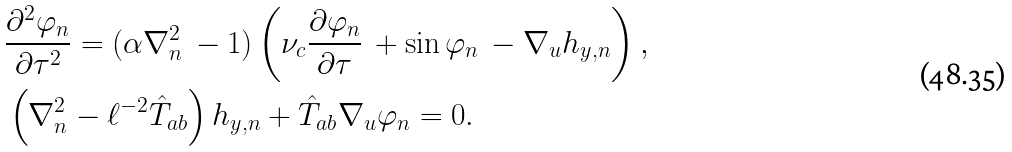Convert formula to latex. <formula><loc_0><loc_0><loc_500><loc_500>& \frac { \partial ^ { 2 } \varphi _ { n } } { \partial \tau ^ { 2 } } = ( \alpha \nabla _ { n } ^ { 2 } \, - 1 ) \left ( \nu _ { c } \frac { \partial \varphi _ { n } } { \partial \tau } \, + \sin \varphi _ { n } \, - \nabla _ { u } h _ { y , n } \right ) , \\ & \left ( \nabla _ { n } ^ { 2 } - \ell ^ { - 2 } \hat { T } _ { a b } \right ) h _ { y , n } + \hat { T } _ { a b } \nabla _ { u } \varphi _ { n } = 0 .</formula> 